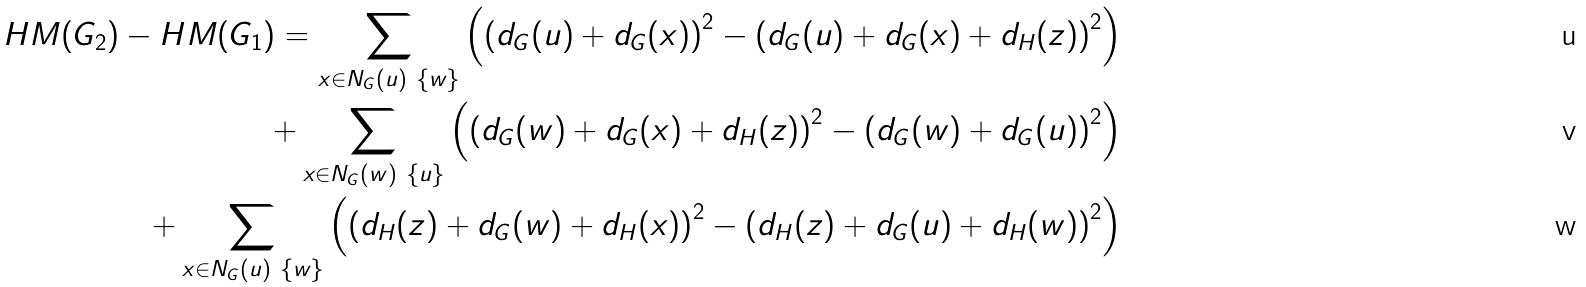<formula> <loc_0><loc_0><loc_500><loc_500>H M ( G _ { 2 } ) - H M ( G _ { 1 } ) = \sum _ { x \in N _ { G } ( u ) \ \{ w \} } \left ( \left ( d _ { G } ( u ) + d _ { G } ( x ) \right ) ^ { 2 } - \left ( d _ { G } ( u ) + d _ { G } ( x ) + d _ { H } ( z ) \right ) ^ { 2 } \right ) \\ + \sum _ { x \in N _ { G } ( w ) \ \{ u \} } \left ( \left ( d _ { G } ( w ) + d _ { G } ( x ) + d _ { H } ( z ) \right ) ^ { 2 } - \left ( d _ { G } ( w ) + d _ { G } ( u ) \right ) ^ { 2 } \right ) \\ + \sum _ { x \in N _ { G } ( u ) \ \{ w \} } \left ( \left ( d _ { H } ( z ) + d _ { G } ( w ) + d _ { H } ( x ) \right ) ^ { 2 } - \left ( d _ { H } ( z ) + d _ { G } ( u ) + d _ { H } ( w ) \right ) ^ { 2 } \right )</formula> 